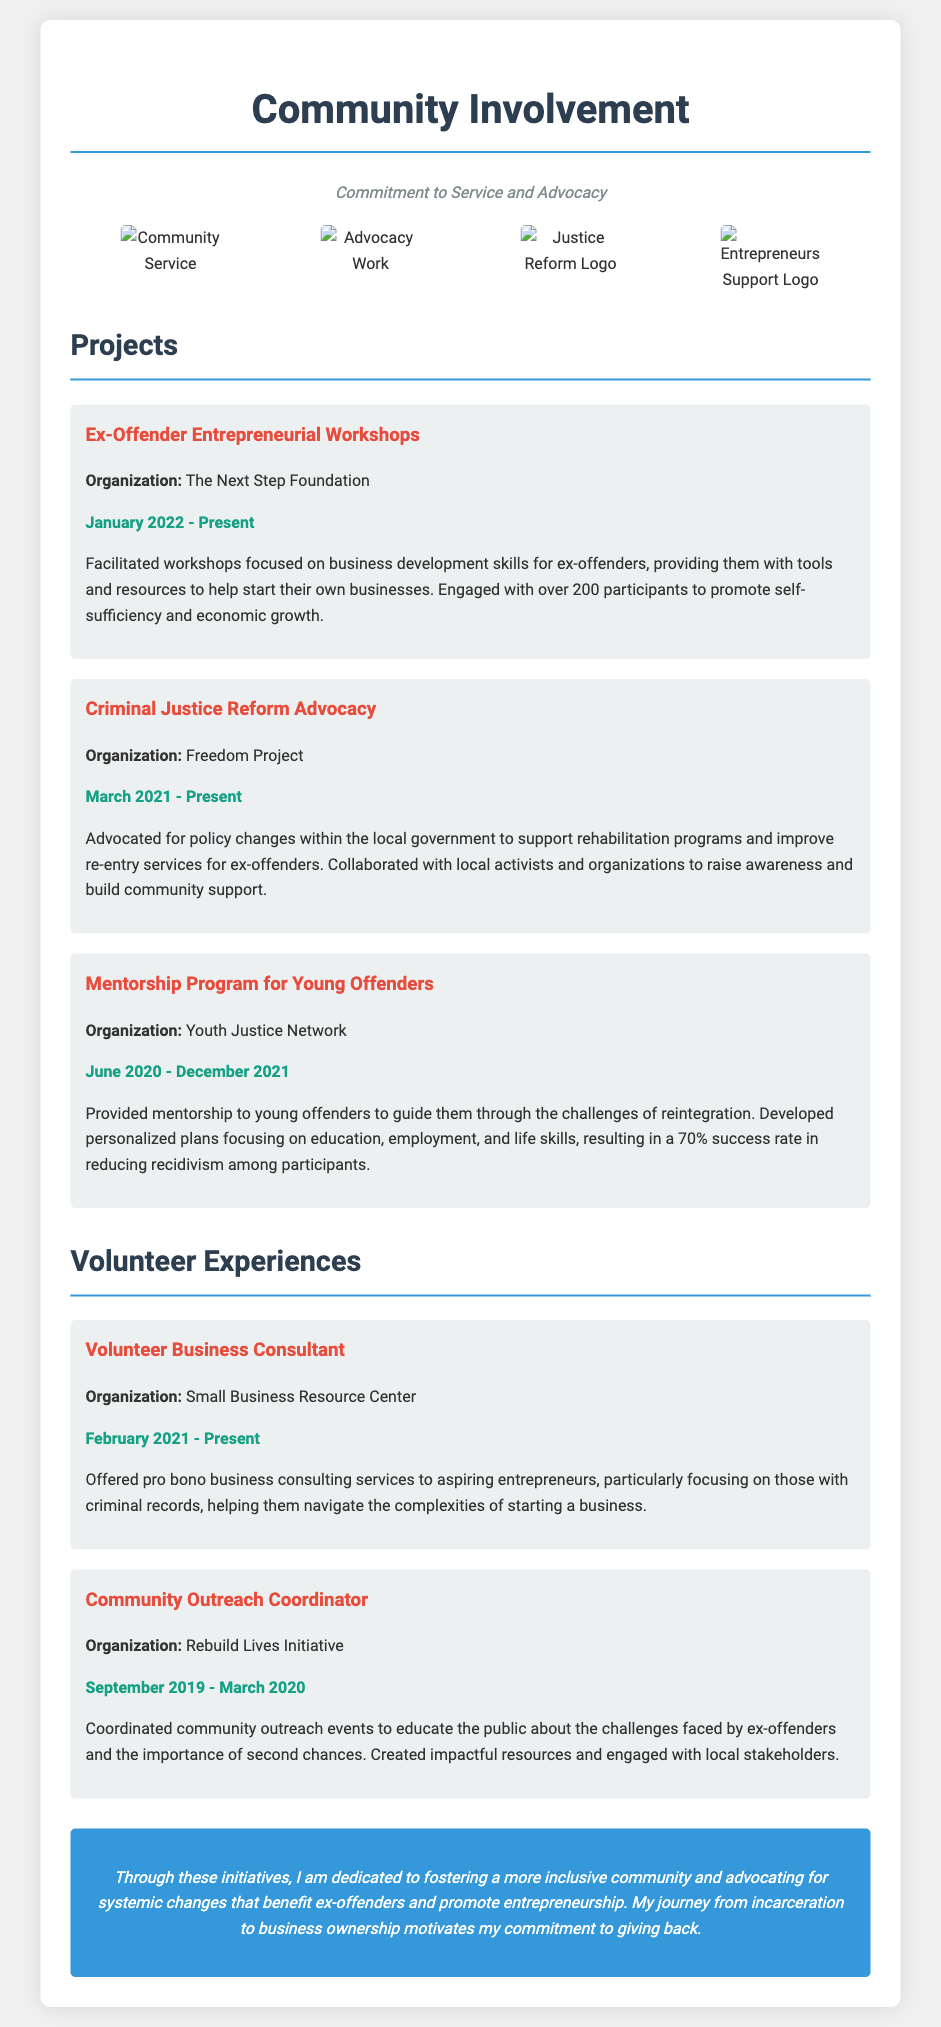what is the title of this document? The main title of the document is prominently displayed at the top.
Answer: Community Involvement which organization is associated with the Ex-Offender Entrepreneurial Workshops? The organization name is mentioned in the project description for the workshops.
Answer: The Next Step Foundation how many participants engaged in the workshops? The document states the number of participants reached through the workshops.
Answer: over 200 when did the Criminal Justice Reform Advocacy start? The date is clearly indicated in the project description.
Answer: March 2021 what was the success rate in the Mentorship Program for Young Offenders? The success rate is specified in the description of the mentorship program.
Answer: 70% which organization did the Volunteer Business Consultant service? The organization's name is mentioned in the volunteer experiences section.
Answer: Small Business Resource Center what is the duration of the Community Outreach Coordinator role? The start and end date provides the duration of the experience.
Answer: September 2019 - March 2020 how does the author view their past experiences? The author's perspective on their journey is reflected in the concluding statement.
Answer: motivates my commitment to giving back 